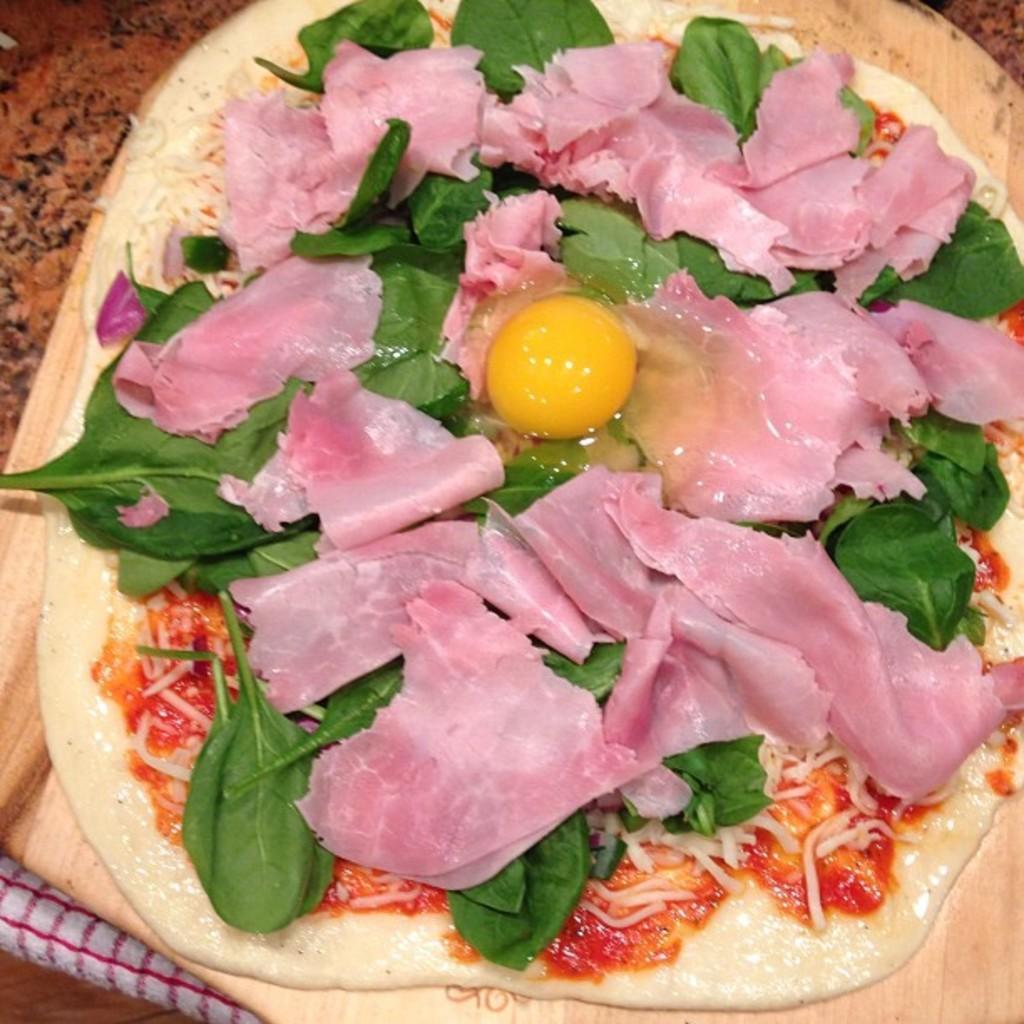Can you describe this image briefly? In this image, we can see a table, on the table, we can see white and red color cloth and a pan, on the pan, we can see some food item. 